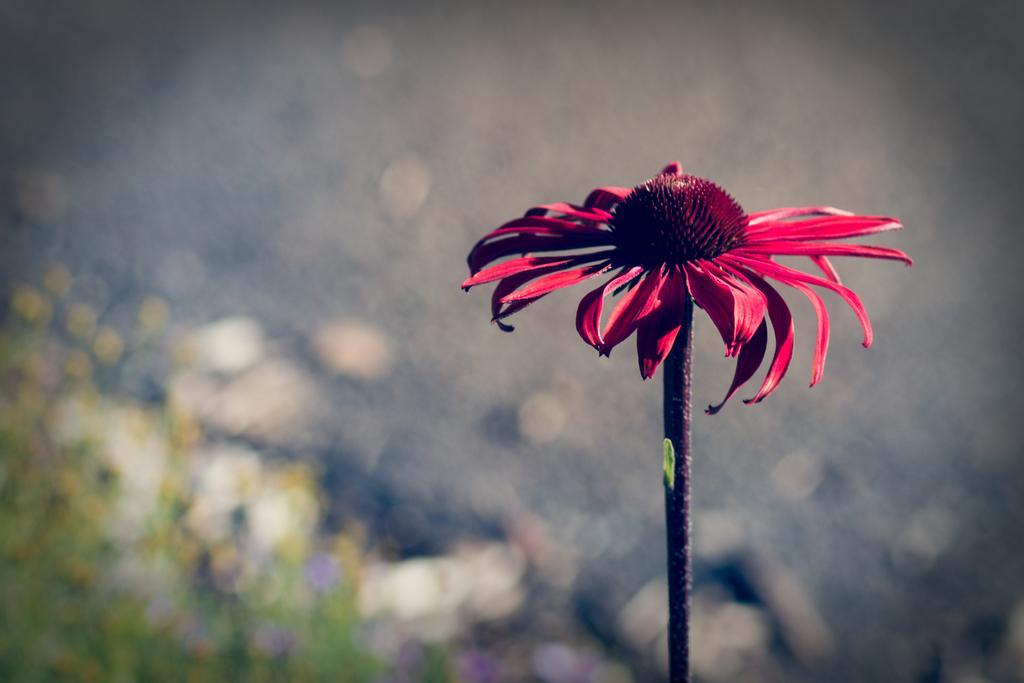Could you give a brief overview of what you see in this image? In this picture I can see there is a red color flower and it has red color petals and a stem and the backdrop is blurred. 